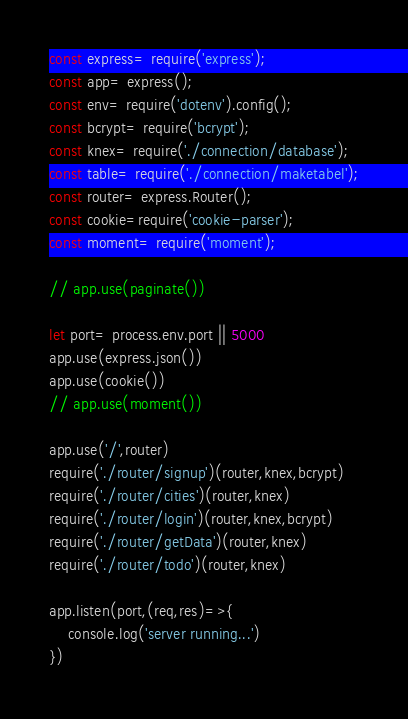<code> <loc_0><loc_0><loc_500><loc_500><_JavaScript_>const express= require('express');
const app= express();
const env= require('dotenv').config();
const bcrypt= require('bcrypt');
const knex= require('./connection/database');
const table= require('./connection/maketabel');
const router= express.Router();
const cookie=require('cookie-parser');
const moment= require('moment');

// app.use(paginate())

let port= process.env.port || 5000
app.use(express.json())
app.use(cookie())
// app.use(moment())

app.use('/',router)
require('./router/signup')(router,knex,bcrypt)
require('./router/cities')(router,knex)
require('./router/login')(router,knex,bcrypt)
require('./router/getData')(router,knex)
require('./router/todo')(router,knex)

app.listen(port,(req,res)=>{
    console.log('server running...')
})
</code> 